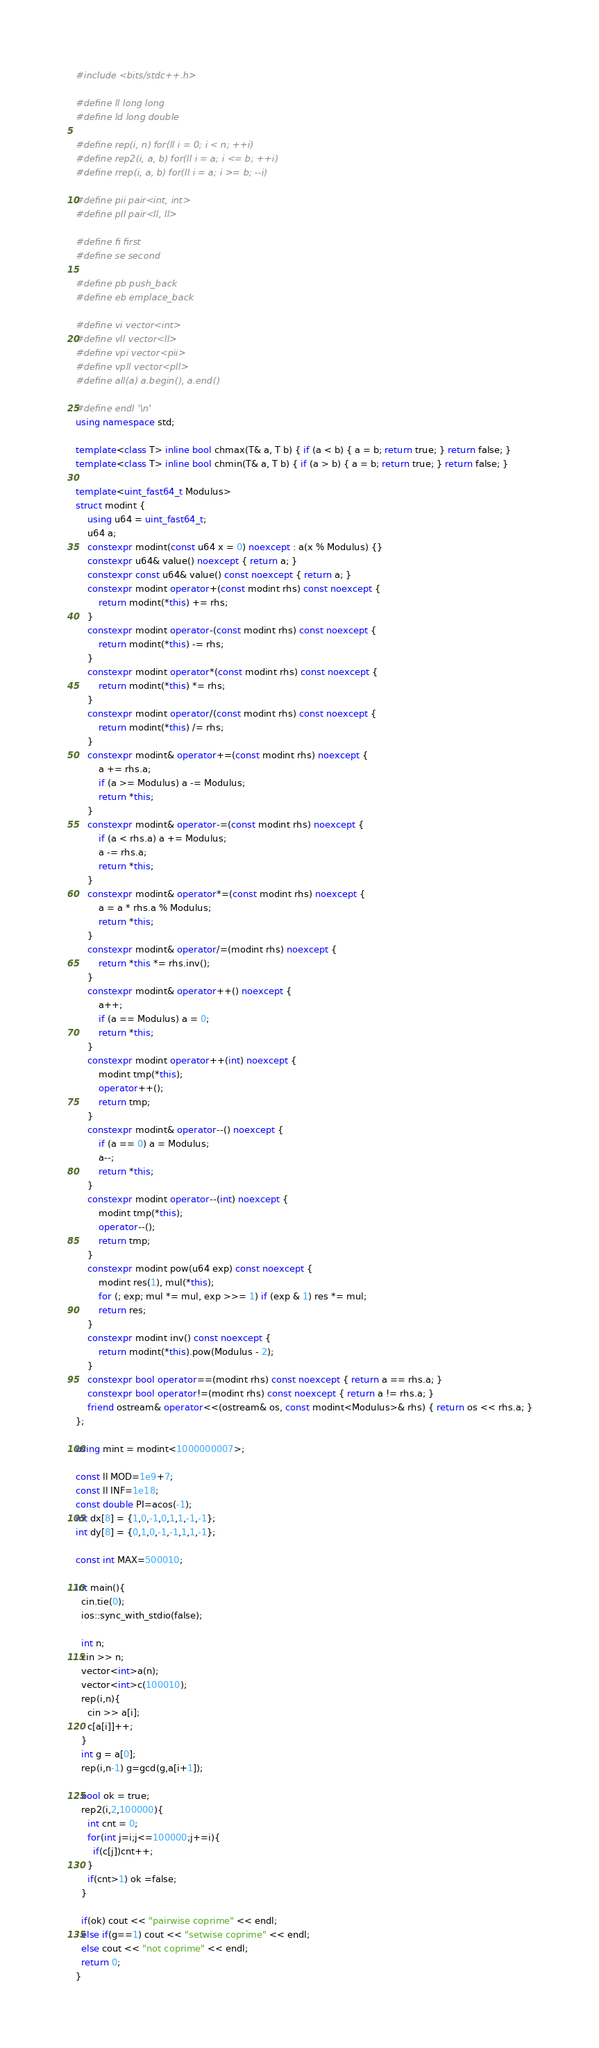Convert code to text. <code><loc_0><loc_0><loc_500><loc_500><_C++_>#include <bits/stdc++.h>

#define ll long long
#define ld long double

#define rep(i, n) for(ll i = 0; i < n; ++i)
#define rep2(i, a, b) for(ll i = a; i <= b; ++i)
#define rrep(i, a, b) for(ll i = a; i >= b; --i)

#define pii pair<int, int>
#define pll pair<ll, ll>

#define fi first
#define se second

#define pb push_back
#define eb emplace_back

#define vi vector<int>
#define vll vector<ll>
#define vpi vector<pii>
#define vpll vector<pll>
#define all(a) a.begin(), a.end()

#define endl '\n'
using namespace std;

template<class T> inline bool chmax(T& a, T b) { if (a < b) { a = b; return true; } return false; }
template<class T> inline bool chmin(T& a, T b) { if (a > b) { a = b; return true; } return false; }

template<uint_fast64_t Modulus>
struct modint {
    using u64 = uint_fast64_t;
    u64 a;
    constexpr modint(const u64 x = 0) noexcept : a(x % Modulus) {}
    constexpr u64& value() noexcept { return a; }
    constexpr const u64& value() const noexcept { return a; }
    constexpr modint operator+(const modint rhs) const noexcept {
        return modint(*this) += rhs;
    }
    constexpr modint operator-(const modint rhs) const noexcept {
        return modint(*this) -= rhs;
    }
    constexpr modint operator*(const modint rhs) const noexcept {
        return modint(*this) *= rhs;
    }
    constexpr modint operator/(const modint rhs) const noexcept {
        return modint(*this) /= rhs;
    }
    constexpr modint& operator+=(const modint rhs) noexcept {
        a += rhs.a;
        if (a >= Modulus) a -= Modulus;
        return *this;
    }
    constexpr modint& operator-=(const modint rhs) noexcept {
        if (a < rhs.a) a += Modulus;
        a -= rhs.a;
        return *this;
    }
    constexpr modint& operator*=(const modint rhs) noexcept {
        a = a * rhs.a % Modulus;
        return *this;
    }
    constexpr modint& operator/=(modint rhs) noexcept {
        return *this *= rhs.inv();
    }
    constexpr modint& operator++() noexcept {
        a++;
        if (a == Modulus) a = 0;
        return *this;
    }
    constexpr modint operator++(int) noexcept {
        modint tmp(*this);
        operator++();
        return tmp;
    }
    constexpr modint& operator--() noexcept {
        if (a == 0) a = Modulus;
        a--;
        return *this;
    }
    constexpr modint operator--(int) noexcept {
        modint tmp(*this);
        operator--();
        return tmp;
    }
    constexpr modint pow(u64 exp) const noexcept {
        modint res(1), mul(*this);
        for (; exp; mul *= mul, exp >>= 1) if (exp & 1) res *= mul;
        return res;
    }
    constexpr modint inv() const noexcept {
        return modint(*this).pow(Modulus - 2);
    }
    constexpr bool operator==(modint rhs) const noexcept { return a == rhs.a; }
    constexpr bool operator!=(modint rhs) const noexcept { return a != rhs.a; }
    friend ostream& operator<<(ostream& os, const modint<Modulus>& rhs) { return os << rhs.a; }
};

using mint = modint<1000000007>;

const ll MOD=1e9+7;
const ll INF=1e18;
const double PI=acos(-1);
int dx[8] = {1,0,-1,0,1,1,-1,-1};
int dy[8] = {0,1,0,-1,-1,1,1,-1};
 
const int MAX=500010;

int main(){
  cin.tie(0);
  ios::sync_with_stdio(false); 
   
  int n;
  cin >> n;
  vector<int>a(n);
  vector<int>c(100010);
  rep(i,n){
    cin >> a[i];
    c[a[i]]++;
  }
  int g = a[0];
  rep(i,n-1) g=gcd(g,a[i+1]);
  
  bool ok = true;
  rep2(i,2,100000){
    int cnt = 0;
    for(int j=i;j<=100000;j+=i){
      if(c[j])cnt++;
    }
    if(cnt>1) ok =false;
  }
  
  if(ok) cout << "pairwise coprime" << endl;
  else if(g==1) cout << "setwise coprime" << endl;
  else cout << "not coprime" << endl;
  return 0;
}
</code> 